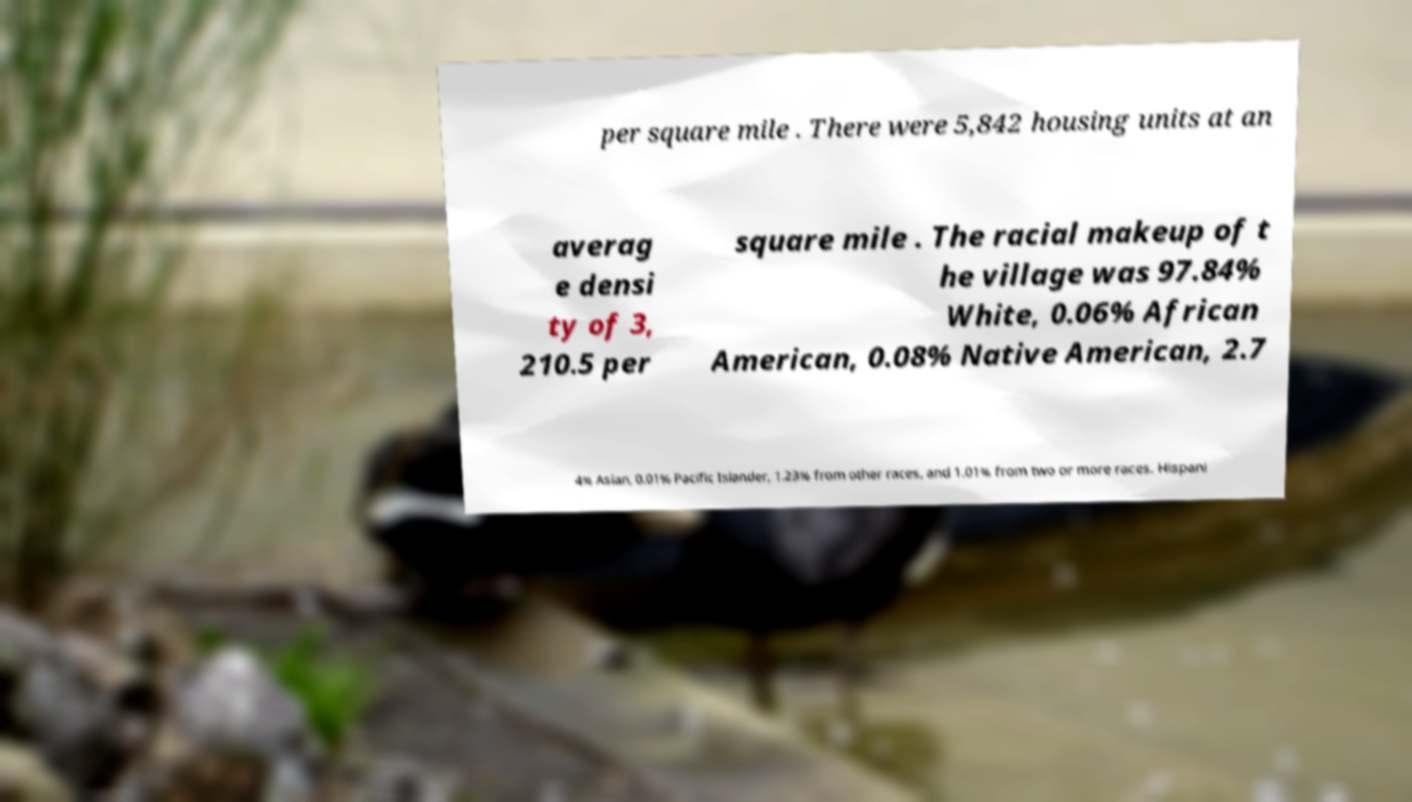Could you assist in decoding the text presented in this image and type it out clearly? per square mile . There were 5,842 housing units at an averag e densi ty of 3, 210.5 per square mile . The racial makeup of t he village was 97.84% White, 0.06% African American, 0.08% Native American, 2.7 4% Asian, 0.01% Pacific Islander, 1.23% from other races, and 1.01% from two or more races. Hispani 